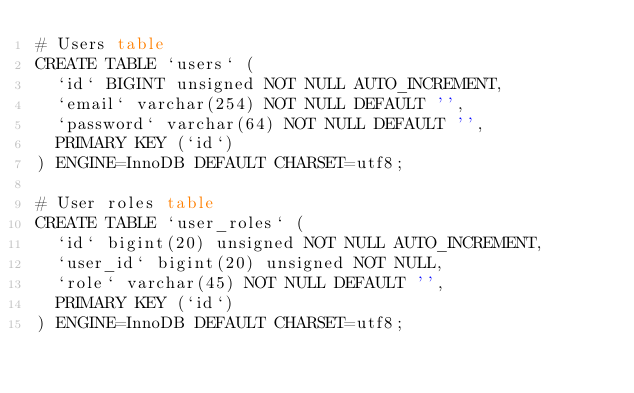<code> <loc_0><loc_0><loc_500><loc_500><_SQL_># Users table
CREATE TABLE `users` (
  `id` BIGINT unsigned NOT NULL AUTO_INCREMENT,
  `email` varchar(254) NOT NULL DEFAULT '',
  `password` varchar(64) NOT NULL DEFAULT '',
  PRIMARY KEY (`id`)
) ENGINE=InnoDB DEFAULT CHARSET=utf8;

# User roles table
CREATE TABLE `user_roles` (
  `id` bigint(20) unsigned NOT NULL AUTO_INCREMENT,
  `user_id` bigint(20) unsigned NOT NULL,
  `role` varchar(45) NOT NULL DEFAULT '',
  PRIMARY KEY (`id`)
) ENGINE=InnoDB DEFAULT CHARSET=utf8;</code> 